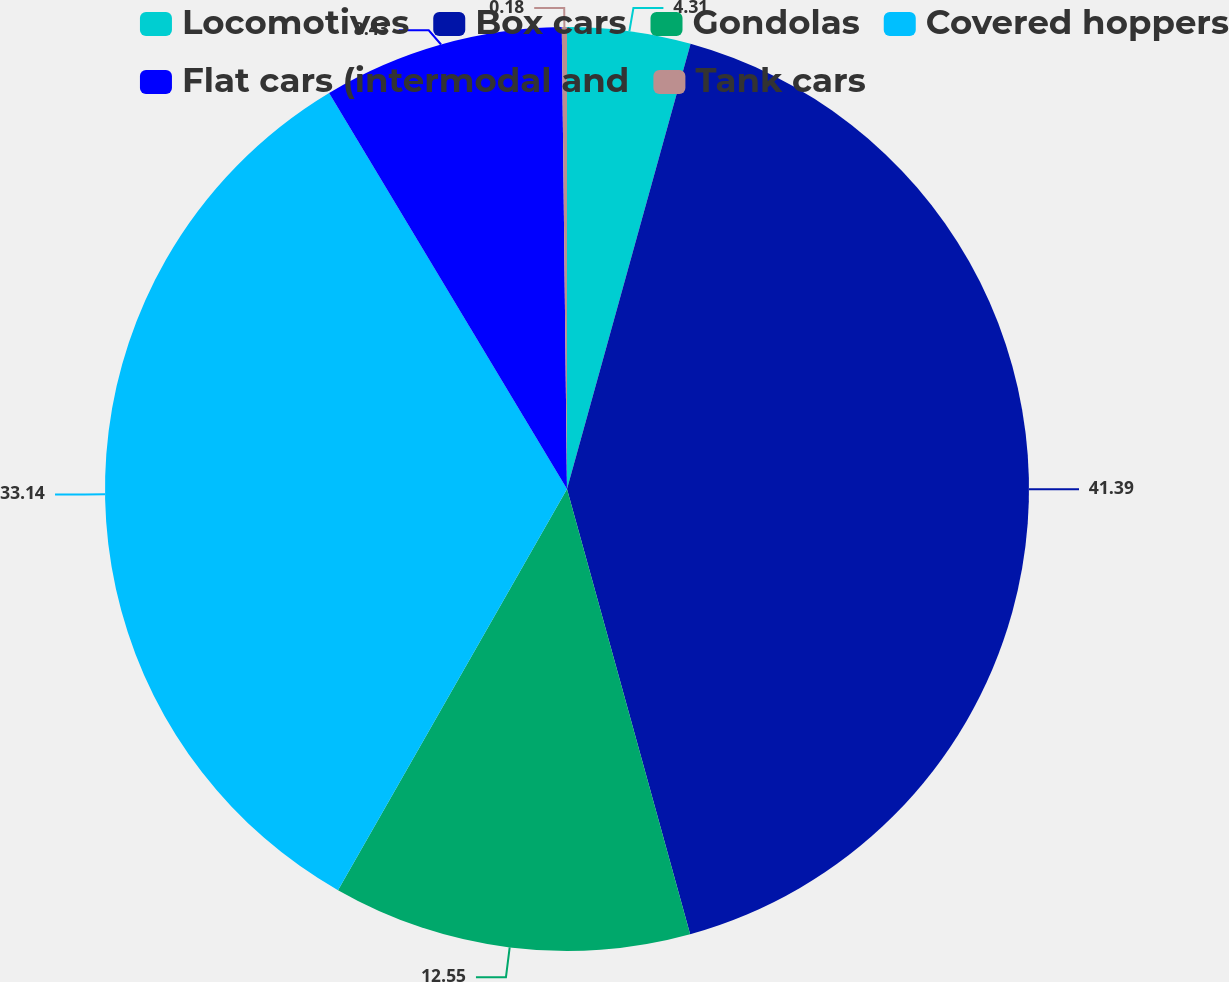<chart> <loc_0><loc_0><loc_500><loc_500><pie_chart><fcel>Locomotives<fcel>Box cars<fcel>Gondolas<fcel>Covered hoppers<fcel>Flat cars (intermodal and<fcel>Tank cars<nl><fcel>4.31%<fcel>41.4%<fcel>12.55%<fcel>33.14%<fcel>8.43%<fcel>0.18%<nl></chart> 